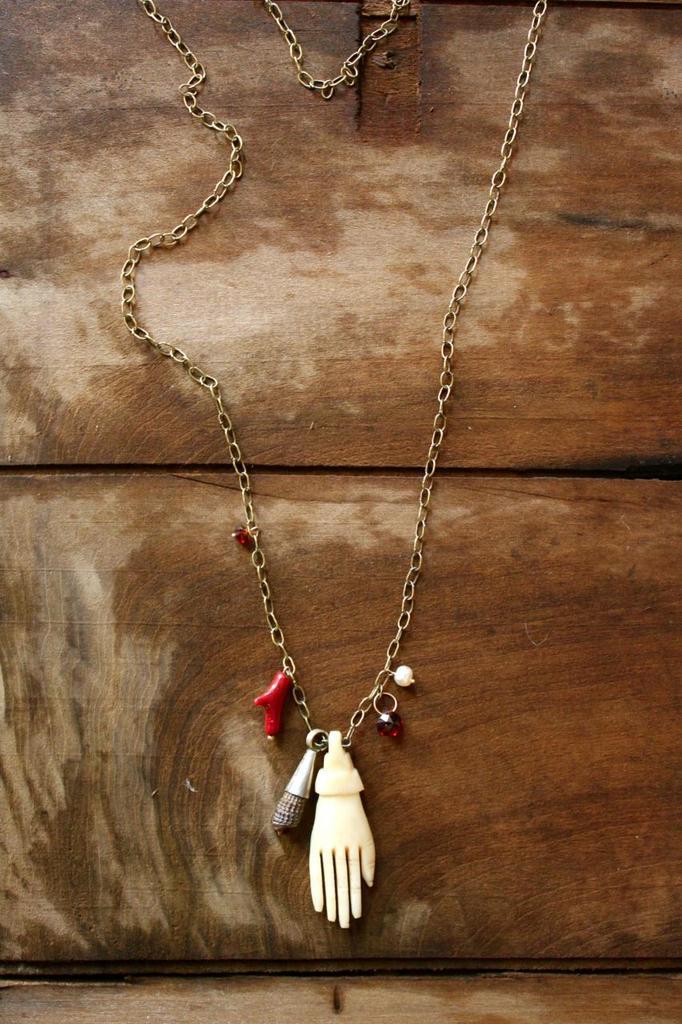Could you give a brief overview of what you see in this image? In the image I can see a chain which has objects attached to it. The chain is on a wooden surface. 